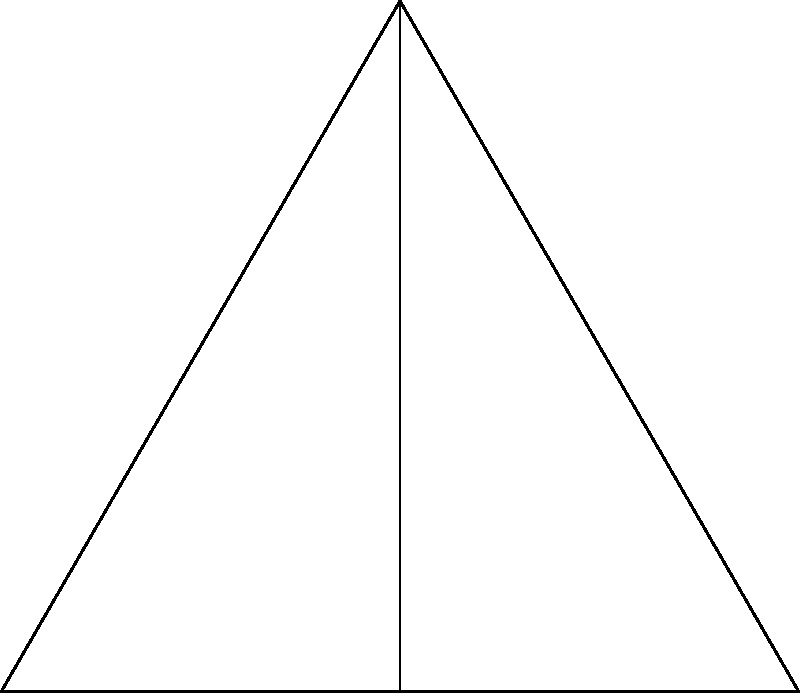In creating a symmetrical eyeshadow look, you decide to use an equilateral triangle shape as your base. If you rotate this triangle shape around its center point to create a complete eyeshadow pattern, how many degrees of rotation are needed to bring the triangle back to its original position? Let's approach this step-by-step:

1) First, we need to understand the properties of an equilateral triangle:
   - All sides are equal in length
   - All internal angles are equal, each measuring 60°

2) In the diagram, triangle ABC is our original equilateral triangle.

3) Point O is the center of rotation, which is also the center of the circle that circumscribes the triangle.

4) When we rotate the triangle, we're essentially creating copies of it around point O.

5) To bring the triangle back to its original position, we need to complete a full rotation of 360°.

6) However, due to the symmetry of an equilateral triangle, it will align with its original position multiple times during a full rotation.

7) Specifically, it will align every 120°, because:
   - 360° ÷ 3 = 120°
   - This is because an equilateral triangle has 3-fold rotational symmetry

8) Therefore, the triangle will return to its original position after rotations of 120°, 240°, and 360°.

9) The smallest rotation that brings the triangle back to its original position is 120°.

Thus, 120° of rotation is needed to bring the triangle back to its original position.
Answer: 120° 